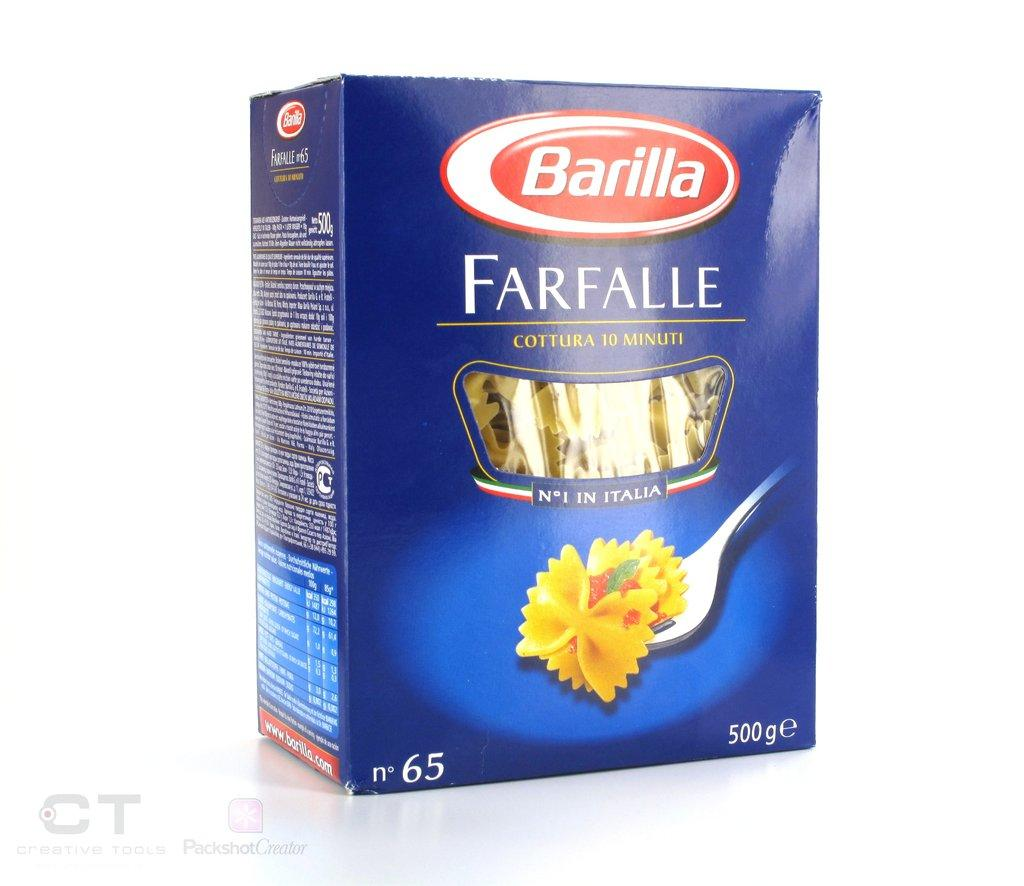What object is present in the image? There is a box in the image. Where is the box located? The box is on a white surface. What can be found at the bottom left of the image? There is text at the bottom left of the image. What type of symbol is present in the image? There is a logo in the image. What type of support can be seen in the image? There is no support visible in the image; it only features a box, text, and a logo. What kind of protest is taking place in the image? There is no protest depicted in the image; it only features a box, text, and a logo. 